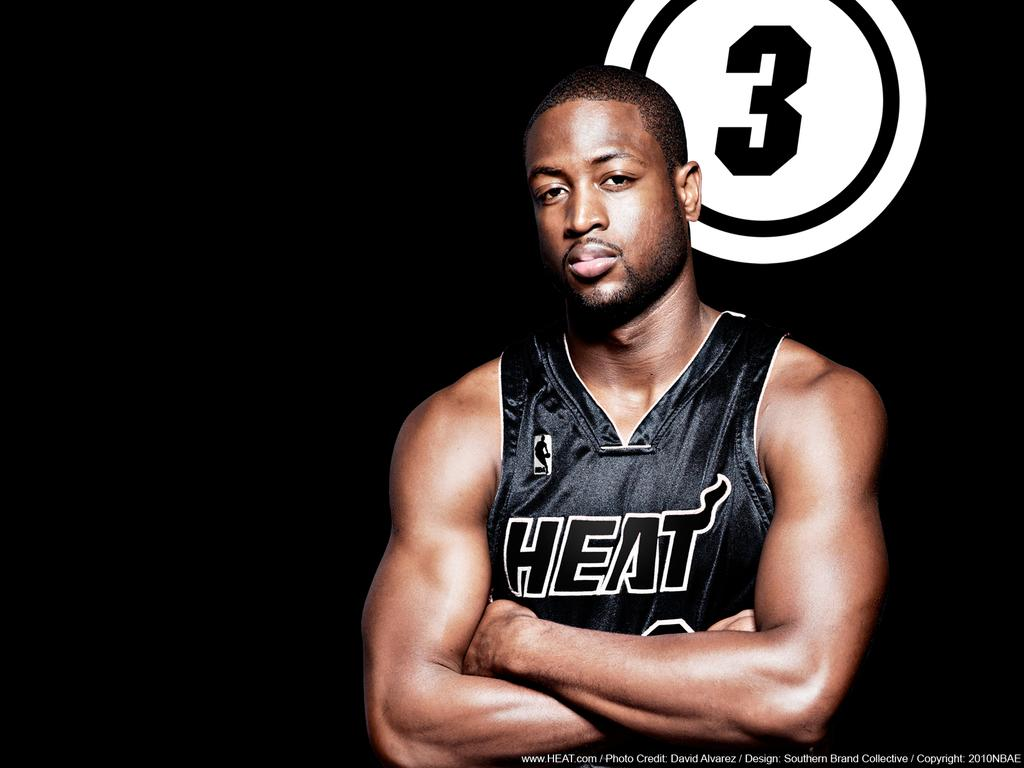<image>
Summarize the visual content of the image. A Miami Heat basketball player poses for a picture. 